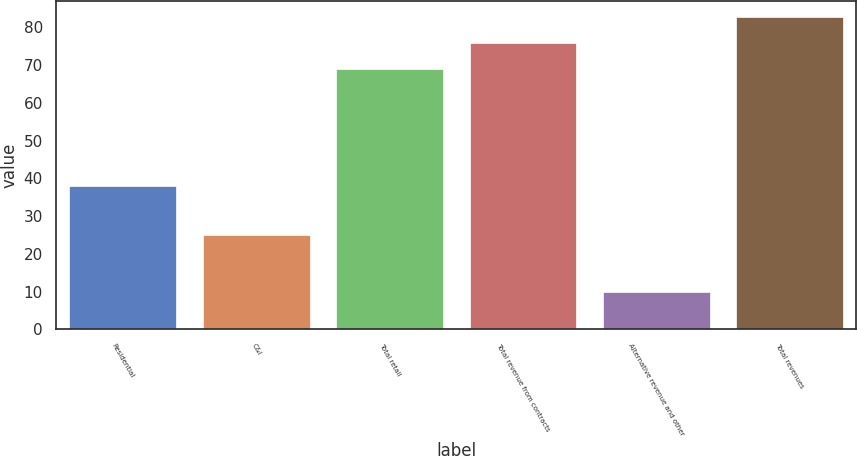Convert chart to OTSL. <chart><loc_0><loc_0><loc_500><loc_500><bar_chart><fcel>Residential<fcel>C&I<fcel>Total retail<fcel>Total revenue from contracts<fcel>Alternative revenue and other<fcel>Total revenues<nl><fcel>38<fcel>25<fcel>69<fcel>75.9<fcel>10<fcel>82.8<nl></chart> 